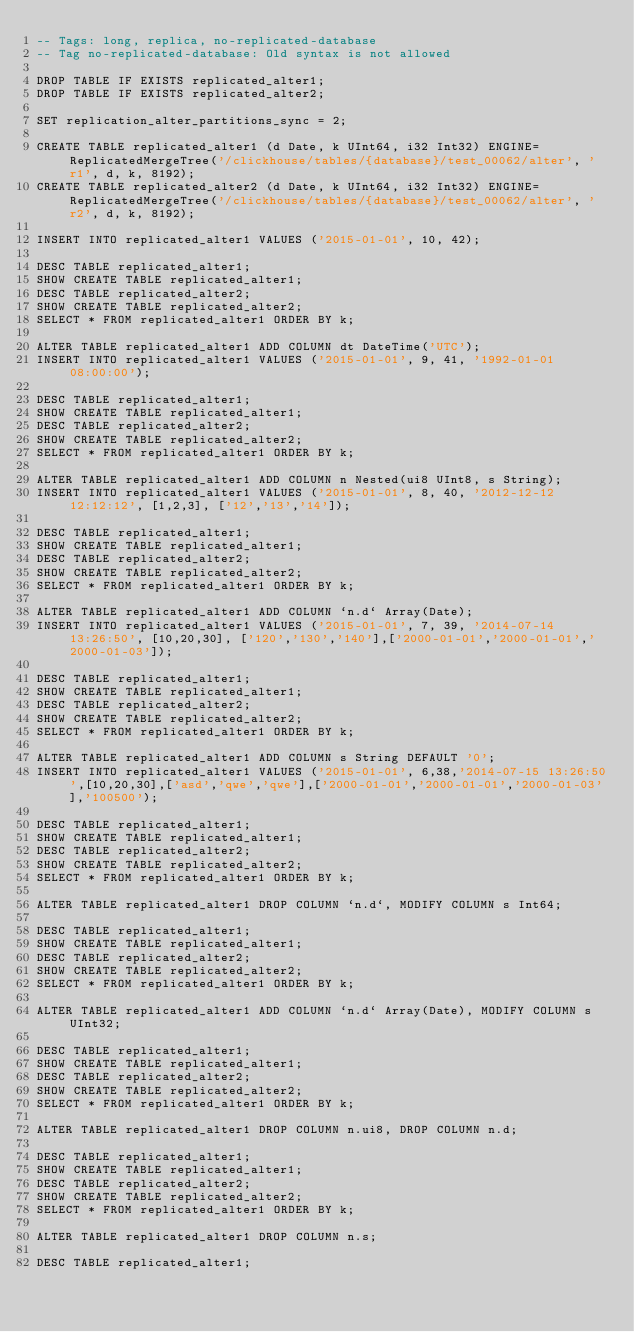Convert code to text. <code><loc_0><loc_0><loc_500><loc_500><_SQL_>-- Tags: long, replica, no-replicated-database
-- Tag no-replicated-database: Old syntax is not allowed

DROP TABLE IF EXISTS replicated_alter1;
DROP TABLE IF EXISTS replicated_alter2;

SET replication_alter_partitions_sync = 2;

CREATE TABLE replicated_alter1 (d Date, k UInt64, i32 Int32) ENGINE=ReplicatedMergeTree('/clickhouse/tables/{database}/test_00062/alter', 'r1', d, k, 8192);
CREATE TABLE replicated_alter2 (d Date, k UInt64, i32 Int32) ENGINE=ReplicatedMergeTree('/clickhouse/tables/{database}/test_00062/alter', 'r2', d, k, 8192);

INSERT INTO replicated_alter1 VALUES ('2015-01-01', 10, 42);

DESC TABLE replicated_alter1;
SHOW CREATE TABLE replicated_alter1;
DESC TABLE replicated_alter2;
SHOW CREATE TABLE replicated_alter2;
SELECT * FROM replicated_alter1 ORDER BY k;

ALTER TABLE replicated_alter1 ADD COLUMN dt DateTime('UTC');
INSERT INTO replicated_alter1 VALUES ('2015-01-01', 9, 41, '1992-01-01 08:00:00');

DESC TABLE replicated_alter1;
SHOW CREATE TABLE replicated_alter1;
DESC TABLE replicated_alter2;
SHOW CREATE TABLE replicated_alter2;
SELECT * FROM replicated_alter1 ORDER BY k;

ALTER TABLE replicated_alter1 ADD COLUMN n Nested(ui8 UInt8, s String);
INSERT INTO replicated_alter1 VALUES ('2015-01-01', 8, 40, '2012-12-12 12:12:12', [1,2,3], ['12','13','14']);

DESC TABLE replicated_alter1;
SHOW CREATE TABLE replicated_alter1;
DESC TABLE replicated_alter2;
SHOW CREATE TABLE replicated_alter2;
SELECT * FROM replicated_alter1 ORDER BY k;

ALTER TABLE replicated_alter1 ADD COLUMN `n.d` Array(Date);
INSERT INTO replicated_alter1 VALUES ('2015-01-01', 7, 39, '2014-07-14 13:26:50', [10,20,30], ['120','130','140'],['2000-01-01','2000-01-01','2000-01-03']);

DESC TABLE replicated_alter1;
SHOW CREATE TABLE replicated_alter1;
DESC TABLE replicated_alter2;
SHOW CREATE TABLE replicated_alter2;
SELECT * FROM replicated_alter1 ORDER BY k;

ALTER TABLE replicated_alter1 ADD COLUMN s String DEFAULT '0';
INSERT INTO replicated_alter1 VALUES ('2015-01-01', 6,38,'2014-07-15 13:26:50',[10,20,30],['asd','qwe','qwe'],['2000-01-01','2000-01-01','2000-01-03'],'100500');

DESC TABLE replicated_alter1;
SHOW CREATE TABLE replicated_alter1;
DESC TABLE replicated_alter2;
SHOW CREATE TABLE replicated_alter2;
SELECT * FROM replicated_alter1 ORDER BY k;

ALTER TABLE replicated_alter1 DROP COLUMN `n.d`, MODIFY COLUMN s Int64;

DESC TABLE replicated_alter1;
SHOW CREATE TABLE replicated_alter1;
DESC TABLE replicated_alter2;
SHOW CREATE TABLE replicated_alter2;
SELECT * FROM replicated_alter1 ORDER BY k;

ALTER TABLE replicated_alter1 ADD COLUMN `n.d` Array(Date), MODIFY COLUMN s UInt32;

DESC TABLE replicated_alter1;
SHOW CREATE TABLE replicated_alter1;
DESC TABLE replicated_alter2;
SHOW CREATE TABLE replicated_alter2;
SELECT * FROM replicated_alter1 ORDER BY k;

ALTER TABLE replicated_alter1 DROP COLUMN n.ui8, DROP COLUMN n.d;

DESC TABLE replicated_alter1;
SHOW CREATE TABLE replicated_alter1;
DESC TABLE replicated_alter2;
SHOW CREATE TABLE replicated_alter2;
SELECT * FROM replicated_alter1 ORDER BY k;

ALTER TABLE replicated_alter1 DROP COLUMN n.s;

DESC TABLE replicated_alter1;</code> 